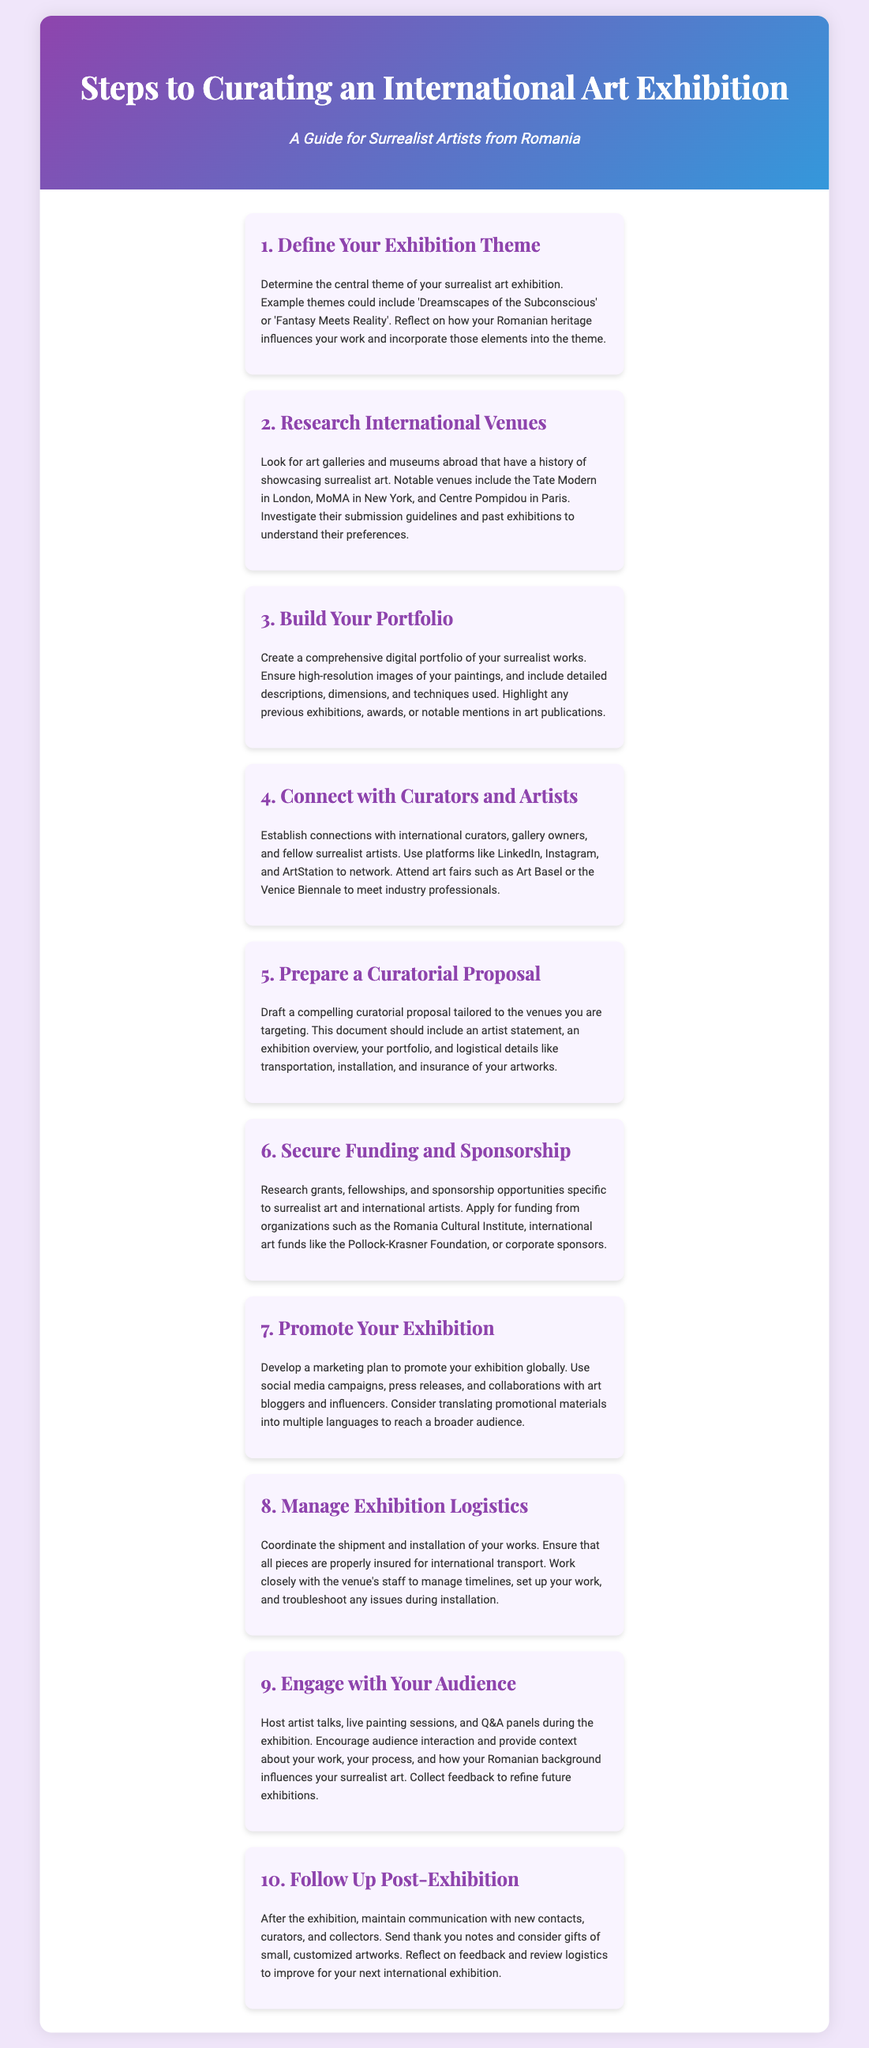What is the first step in curating an international art exhibition? The first step is to define your exhibition theme, which is essential for setting the direction of the exhibition.
Answer: Define Your Exhibition Theme Which museum is mentioned as a notable venue in New York? The document lists the Museum of Modern Art, indicating its relevance as a venue for surrealist art.
Answer: MoMA What should be included in a curatorial proposal? The proposal should contain several key elements, including an artist statement and logistical details for the exhibition.
Answer: Artist statement, exhibition overview, portfolio, logistical details What is the funding source mentioned for international artists? The document mentions the Romania Cultural Institute among other funding sources for artists seeking grants.
Answer: Romania Cultural Institute How many steps are there in the process of curating an exhibition? The document outlines a finite number of steps, providing a clear structure for the reader to follow.
Answer: 10 What is one way to promote an exhibition? The document suggests using social media campaigns as a method of marketing the exhibition to a wider audience.
Answer: Social media campaigns What type of events can be hosted during the exhibition? The document highlights engagement with the audience through various interactive events related to the artist's work.
Answer: Artist talks, live painting sessions, Q&A panels What should be done after the exhibition concludes? The document recommends maintaining communication with contacts made during the exhibition for networking purposes.
Answer: Follow Up Post-Exhibition 